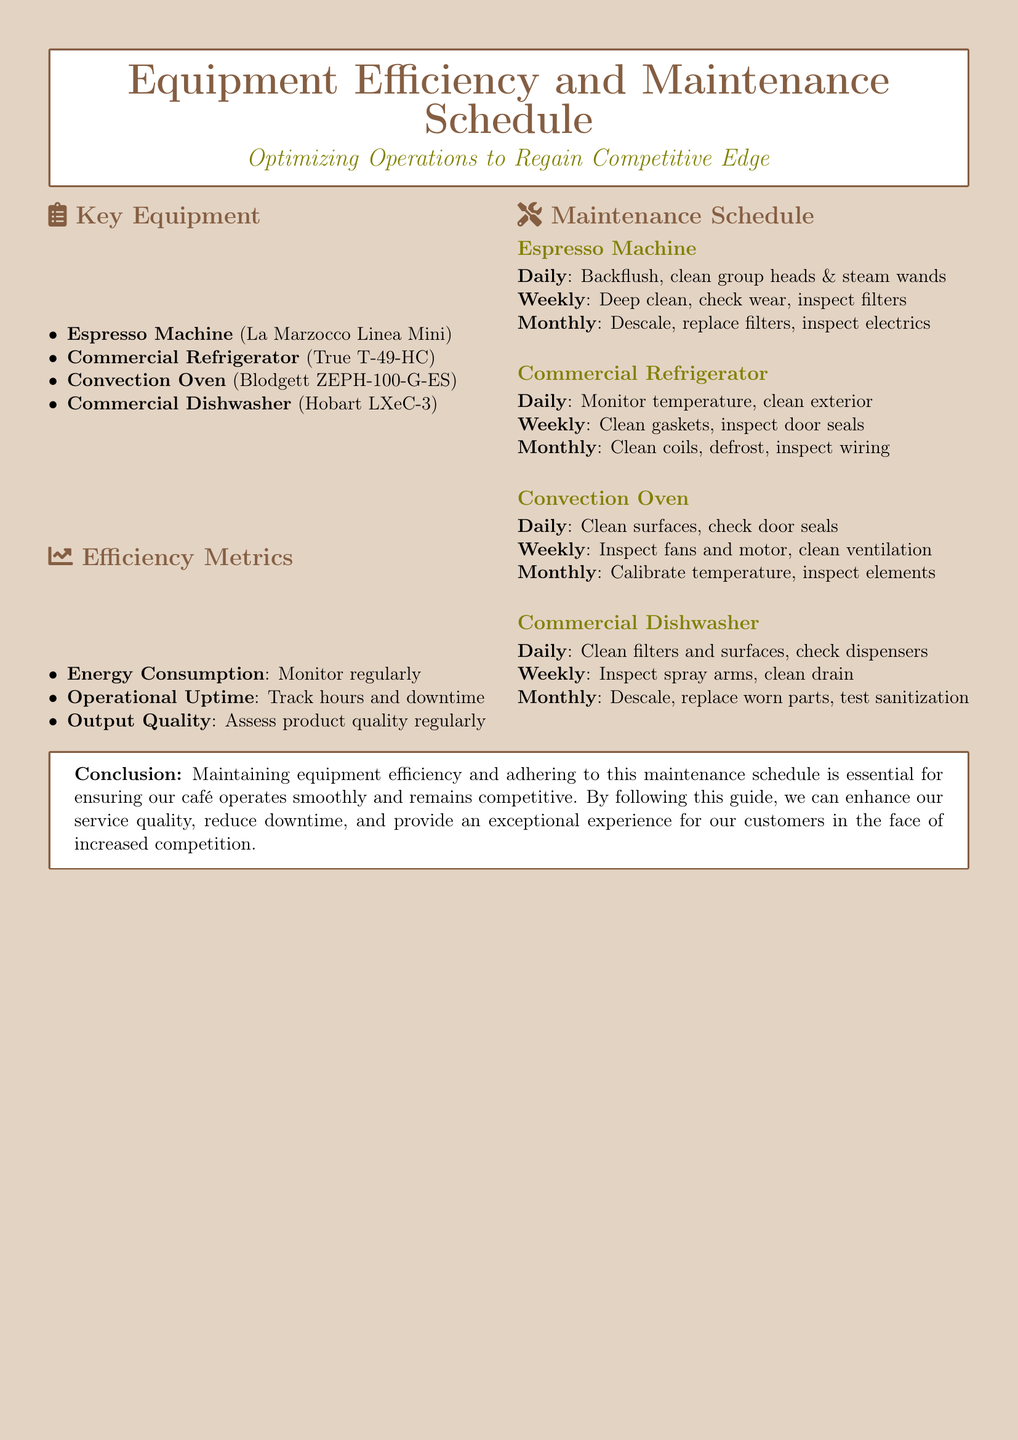what is the model of the espresso machine? The document specifies the espresso machine as La Marzocco Linea Mini.
Answer: La Marzocco Linea Mini how often should the commercial refrigerator's coils be cleaned? The maintenance schedule for the commercial refrigerator states that coils should be cleaned monthly.
Answer: Monthly what is one efficiency metric mentioned in the document? The document lists several efficiency metrics, one of which is energy consumption.
Answer: Energy consumption what is the frequency for the convection oven's temperature calibration? The maintenance schedule indicates that the convection oven's temperature should be calibrated monthly.
Answer: Monthly how many key equipment items are listed in the document? The document outlines four key equipment items.
Answer: Four what maintenance task is required daily for the commercial dishwasher? The commercial dishwasher requires cleaning filters and surfaces daily according to the maintenance schedule.
Answer: Clean filters and surfaces which equipment requires backflushing and cleaning of group heads daily? The document states that the espresso machine requires backflushing and cleaning of group heads daily.
Answer: Espresso Machine what does the conclusion stress about equipment efficiency? The conclusion emphasizes the importance of maintaining equipment efficiency to ensure smooth café operations and competitiveness.
Answer: Essential for ensuring smooth operations what is the color used for section headings in the document? The section headings are presented in the color specified as cafebrown.
Answer: Cafebrown 